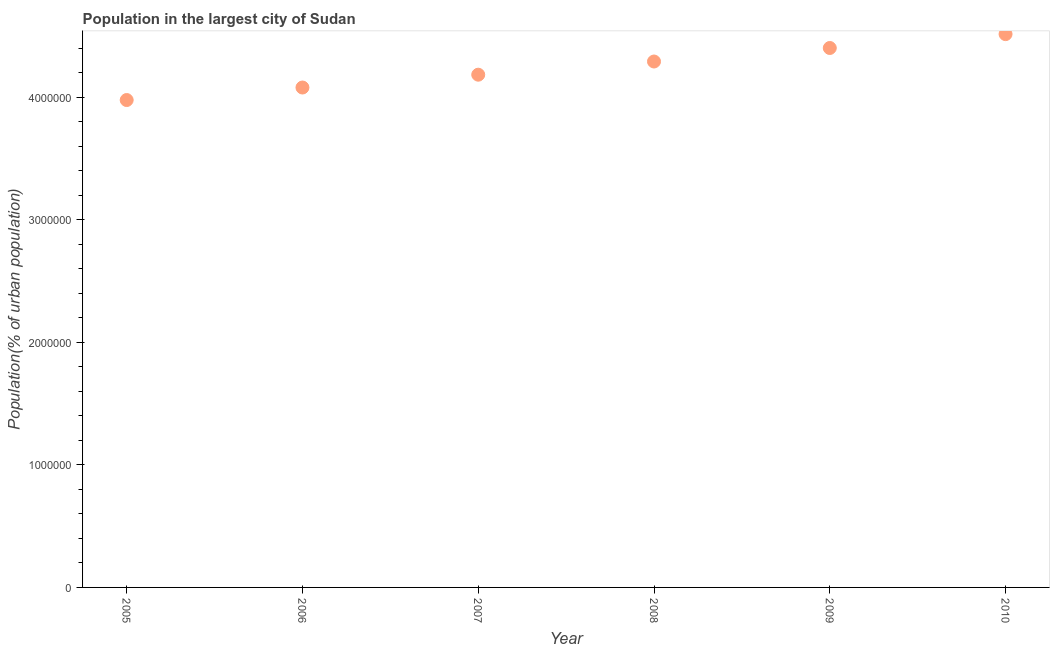What is the population in largest city in 2007?
Keep it short and to the point. 4.19e+06. Across all years, what is the maximum population in largest city?
Make the answer very short. 4.52e+06. Across all years, what is the minimum population in largest city?
Offer a terse response. 3.98e+06. In which year was the population in largest city minimum?
Your answer should be very brief. 2005. What is the sum of the population in largest city?
Ensure brevity in your answer.  2.55e+07. What is the difference between the population in largest city in 2007 and 2010?
Your response must be concise. -3.31e+05. What is the average population in largest city per year?
Ensure brevity in your answer.  4.24e+06. What is the median population in largest city?
Your answer should be very brief. 4.24e+06. In how many years, is the population in largest city greater than 2400000 %?
Offer a very short reply. 6. What is the ratio of the population in largest city in 2005 to that in 2010?
Offer a terse response. 0.88. Is the population in largest city in 2007 less than that in 2009?
Offer a very short reply. Yes. Is the difference between the population in largest city in 2005 and 2009 greater than the difference between any two years?
Provide a short and direct response. No. What is the difference between the highest and the second highest population in largest city?
Your answer should be very brief. 1.13e+05. What is the difference between the highest and the lowest population in largest city?
Your answer should be very brief. 5.38e+05. In how many years, is the population in largest city greater than the average population in largest city taken over all years?
Give a very brief answer. 3. Does the population in largest city monotonically increase over the years?
Your answer should be very brief. Yes. How many years are there in the graph?
Make the answer very short. 6. Does the graph contain any zero values?
Your response must be concise. No. Does the graph contain grids?
Your answer should be compact. No. What is the title of the graph?
Provide a short and direct response. Population in the largest city of Sudan. What is the label or title of the X-axis?
Provide a succinct answer. Year. What is the label or title of the Y-axis?
Give a very brief answer. Population(% of urban population). What is the Population(% of urban population) in 2005?
Give a very brief answer. 3.98e+06. What is the Population(% of urban population) in 2006?
Ensure brevity in your answer.  4.08e+06. What is the Population(% of urban population) in 2007?
Provide a succinct answer. 4.19e+06. What is the Population(% of urban population) in 2008?
Give a very brief answer. 4.29e+06. What is the Population(% of urban population) in 2009?
Offer a very short reply. 4.40e+06. What is the Population(% of urban population) in 2010?
Offer a terse response. 4.52e+06. What is the difference between the Population(% of urban population) in 2005 and 2006?
Provide a succinct answer. -1.02e+05. What is the difference between the Population(% of urban population) in 2005 and 2007?
Keep it short and to the point. -2.07e+05. What is the difference between the Population(% of urban population) in 2005 and 2008?
Offer a very short reply. -3.15e+05. What is the difference between the Population(% of urban population) in 2005 and 2009?
Keep it short and to the point. -4.25e+05. What is the difference between the Population(% of urban population) in 2005 and 2010?
Your answer should be compact. -5.38e+05. What is the difference between the Population(% of urban population) in 2006 and 2007?
Provide a succinct answer. -1.05e+05. What is the difference between the Population(% of urban population) in 2006 and 2008?
Provide a succinct answer. -2.12e+05. What is the difference between the Population(% of urban population) in 2006 and 2009?
Provide a short and direct response. -3.23e+05. What is the difference between the Population(% of urban population) in 2006 and 2010?
Ensure brevity in your answer.  -4.36e+05. What is the difference between the Population(% of urban population) in 2007 and 2008?
Provide a succinct answer. -1.08e+05. What is the difference between the Population(% of urban population) in 2007 and 2009?
Your response must be concise. -2.18e+05. What is the difference between the Population(% of urban population) in 2007 and 2010?
Give a very brief answer. -3.31e+05. What is the difference between the Population(% of urban population) in 2008 and 2009?
Your answer should be very brief. -1.10e+05. What is the difference between the Population(% of urban population) in 2008 and 2010?
Ensure brevity in your answer.  -2.24e+05. What is the difference between the Population(% of urban population) in 2009 and 2010?
Offer a terse response. -1.13e+05. What is the ratio of the Population(% of urban population) in 2005 to that in 2006?
Ensure brevity in your answer.  0.97. What is the ratio of the Population(% of urban population) in 2005 to that in 2007?
Ensure brevity in your answer.  0.95. What is the ratio of the Population(% of urban population) in 2005 to that in 2008?
Ensure brevity in your answer.  0.93. What is the ratio of the Population(% of urban population) in 2005 to that in 2009?
Make the answer very short. 0.9. What is the ratio of the Population(% of urban population) in 2005 to that in 2010?
Offer a terse response. 0.88. What is the ratio of the Population(% of urban population) in 2006 to that in 2007?
Your response must be concise. 0.97. What is the ratio of the Population(% of urban population) in 2006 to that in 2008?
Provide a short and direct response. 0.95. What is the ratio of the Population(% of urban population) in 2006 to that in 2009?
Your response must be concise. 0.93. What is the ratio of the Population(% of urban population) in 2006 to that in 2010?
Your response must be concise. 0.9. What is the ratio of the Population(% of urban population) in 2007 to that in 2009?
Your answer should be very brief. 0.95. What is the ratio of the Population(% of urban population) in 2007 to that in 2010?
Provide a short and direct response. 0.93. What is the ratio of the Population(% of urban population) in 2008 to that in 2010?
Offer a terse response. 0.95. 